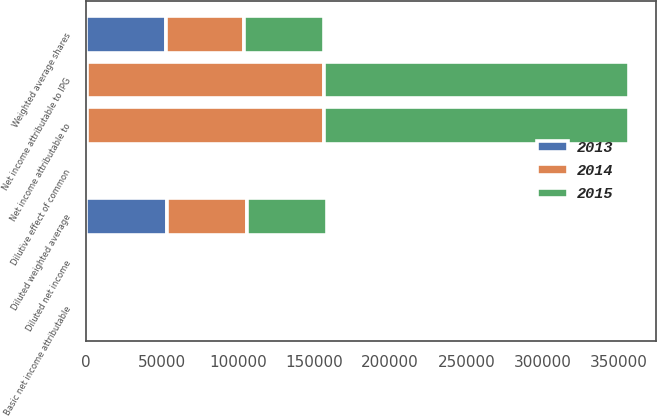Convert chart. <chart><loc_0><loc_0><loc_500><loc_500><stacked_bar_chart><ecel><fcel>Net income attributable to IPG<fcel>Net income attributable to<fcel>Weighted average shares<fcel>Dilutive effect of common<fcel>Diluted weighted average<fcel>Basic net income attributable<fcel>Diluted net income<nl><fcel>2013<fcel>789<fcel>789<fcel>52676<fcel>751<fcel>53427<fcel>4.6<fcel>4.53<nl><fcel>2015<fcel>200445<fcel>200445<fcel>52104<fcel>720<fcel>52824<fcel>3.85<fcel>3.79<nl><fcel>2014<fcel>155780<fcel>155780<fcel>51548<fcel>827<fcel>52375<fcel>3.02<fcel>2.97<nl></chart> 